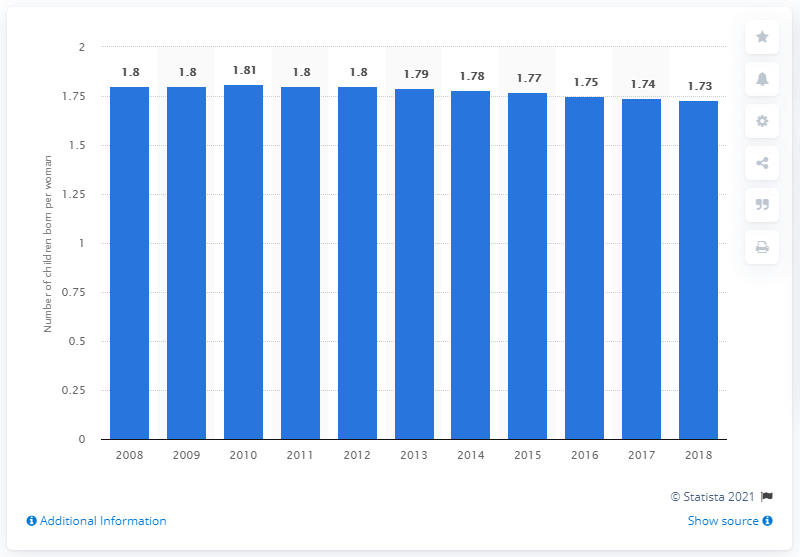Point out several critical features in this image. In 2018, the fertility rate in Trinidad and Tobago was 1.73. 